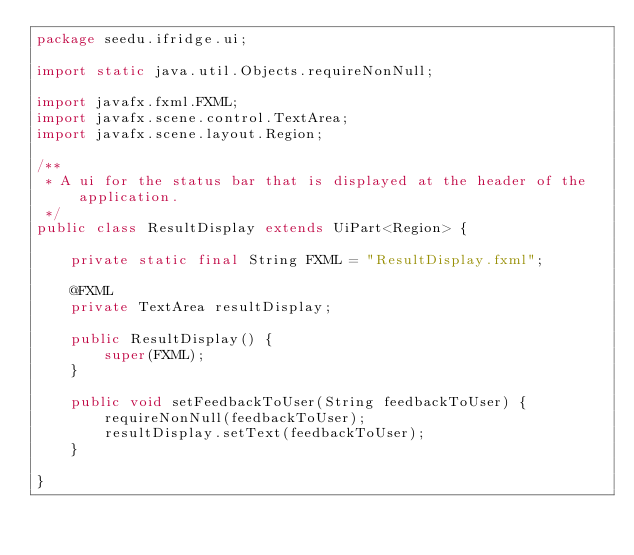Convert code to text. <code><loc_0><loc_0><loc_500><loc_500><_Java_>package seedu.ifridge.ui;

import static java.util.Objects.requireNonNull;

import javafx.fxml.FXML;
import javafx.scene.control.TextArea;
import javafx.scene.layout.Region;

/**
 * A ui for the status bar that is displayed at the header of the application.
 */
public class ResultDisplay extends UiPart<Region> {

    private static final String FXML = "ResultDisplay.fxml";

    @FXML
    private TextArea resultDisplay;

    public ResultDisplay() {
        super(FXML);
    }

    public void setFeedbackToUser(String feedbackToUser) {
        requireNonNull(feedbackToUser);
        resultDisplay.setText(feedbackToUser);
    }

}
</code> 